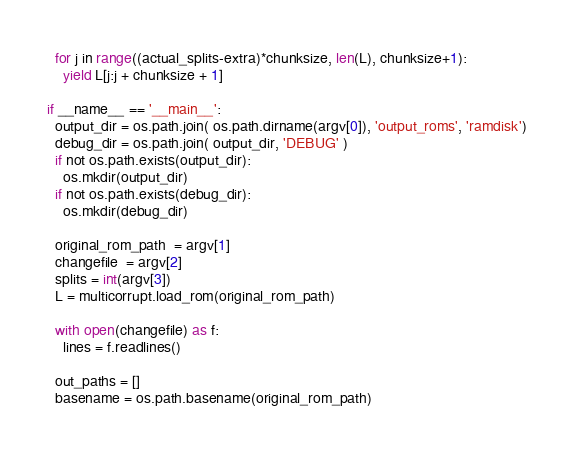<code> <loc_0><loc_0><loc_500><loc_500><_Python_>  for j in range((actual_splits-extra)*chunksize, len(L), chunksize+1):
    yield L[j:j + chunksize + 1]

if __name__ == '__main__':
  output_dir = os.path.join( os.path.dirname(argv[0]), 'output_roms', 'ramdisk')
  debug_dir = os.path.join( output_dir, 'DEBUG' )
  if not os.path.exists(output_dir):
    os.mkdir(output_dir)
  if not os.path.exists(debug_dir):
    os.mkdir(debug_dir)
      
  original_rom_path  = argv[1]
  changefile  = argv[2]
  splits = int(argv[3])
  L = multicorrupt.load_rom(original_rom_path)
  
  with open(changefile) as f:
    lines = f.readlines()
  
  out_paths = []
  basename = os.path.basename(original_rom_path)</code> 